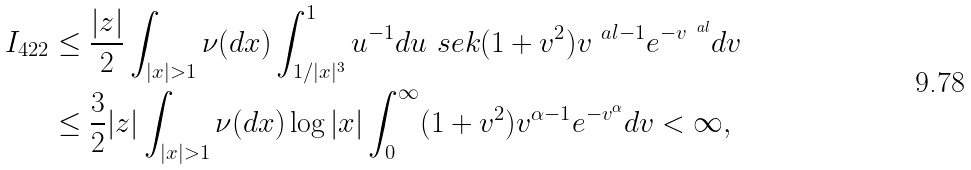Convert formula to latex. <formula><loc_0><loc_0><loc_500><loc_500>I _ { 4 2 2 } & \leq \frac { | z | } { 2 } \int _ { | x | > 1 } \nu ( d x ) \int _ { 1 / | x | ^ { 3 } } ^ { 1 } u ^ { - 1 } d u \ s e k ( 1 + v ^ { 2 } ) v ^ { \ a l - 1 } e ^ { - v ^ { \ a l } } d v \\ & \leq \frac { 3 } { 2 } | z | \int _ { | x | > 1 } \nu ( d x ) \log | x | \int _ { 0 } ^ { \infty } ( 1 + v ^ { 2 } ) v ^ { \alpha - 1 } e ^ { - v ^ { \alpha } } d v < \infty ,</formula> 